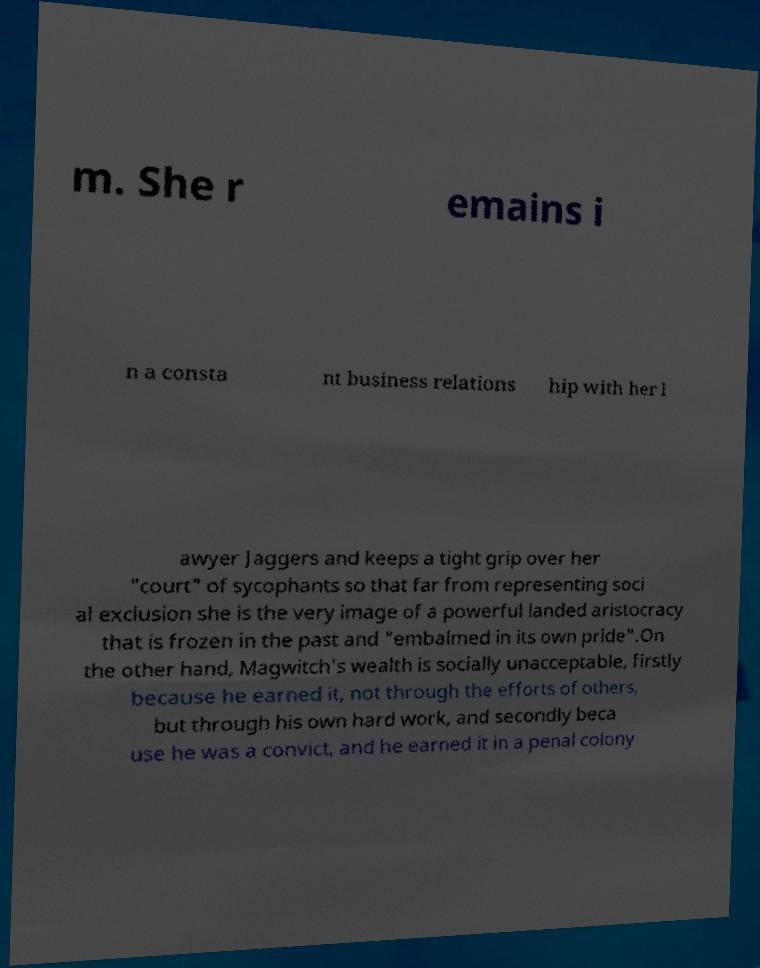Could you assist in decoding the text presented in this image and type it out clearly? m. She r emains i n a consta nt business relations hip with her l awyer Jaggers and keeps a tight grip over her "court" of sycophants so that far from representing soci al exclusion she is the very image of a powerful landed aristocracy that is frozen in the past and "embalmed in its own pride".On the other hand, Magwitch's wealth is socially unacceptable, firstly because he earned it, not through the efforts of others, but through his own hard work, and secondly beca use he was a convict, and he earned it in a penal colony 